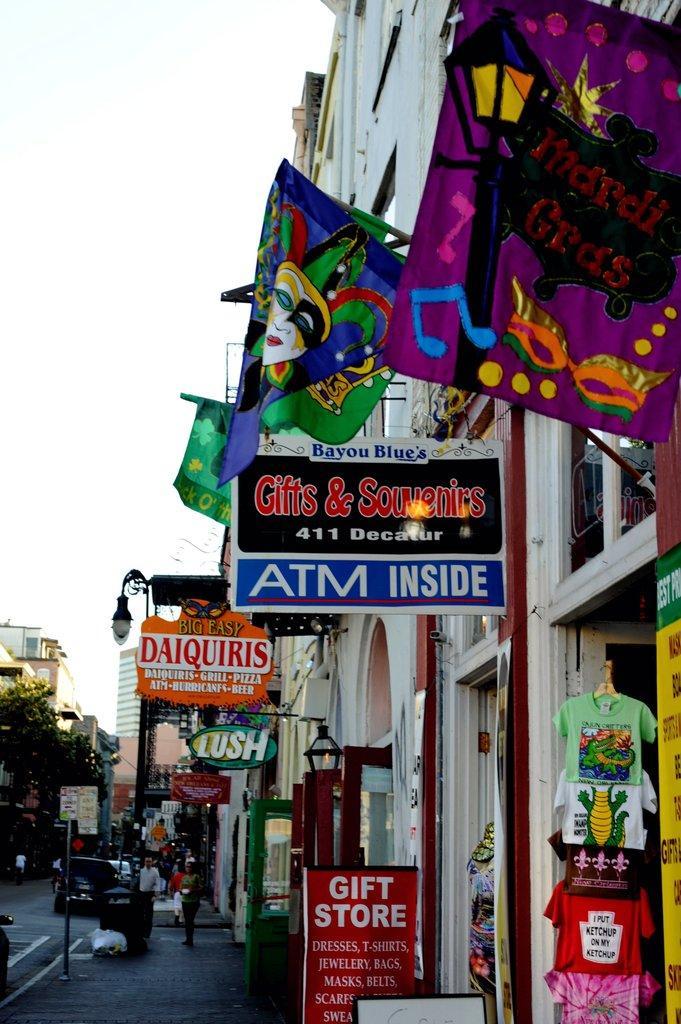How would you summarize this image in a sentence or two? This picture is taken on the wide road. In this image, on the right side, we can see a building, few shirts, hoardings, flags, glass window, lights. In the middle of the image, we can see a group of people are walking on the road. On the left side, we can see few cars, trees. At the top, we can see a sky. 